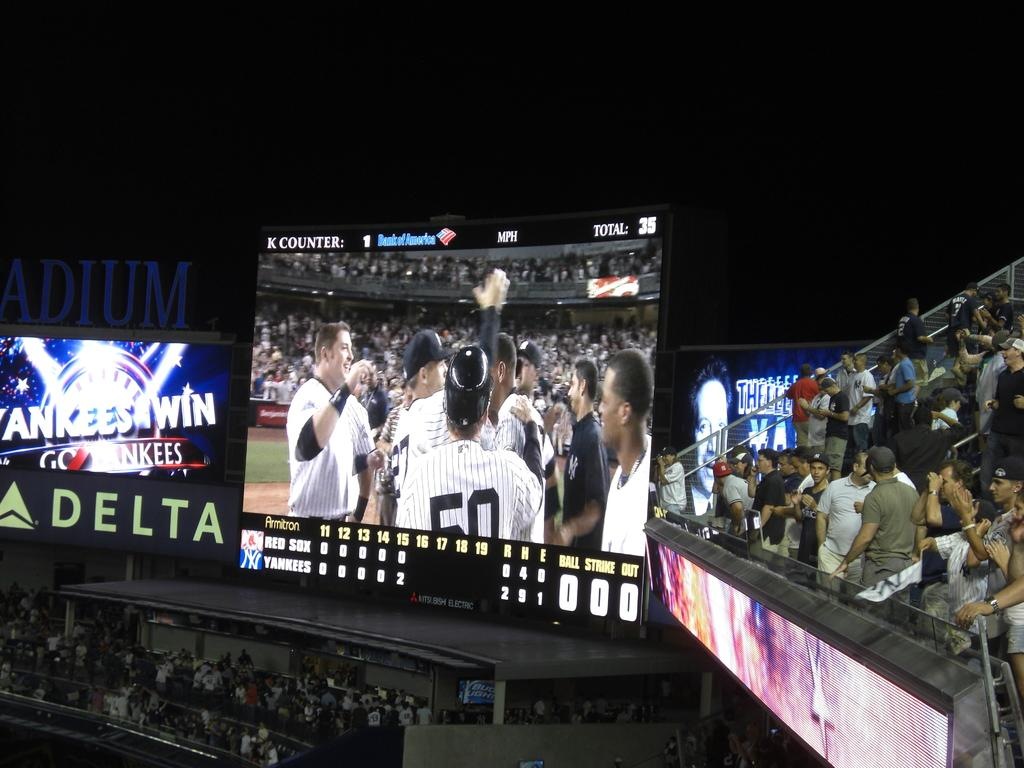<image>
Provide a brief description of the given image. A Delta sign is displayed under an electronic screen at this stadium. 